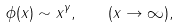<formula> <loc_0><loc_0><loc_500><loc_500>\phi ( x ) \sim x ^ { \gamma } , \quad ( x \rightarrow \infty ) ,</formula> 